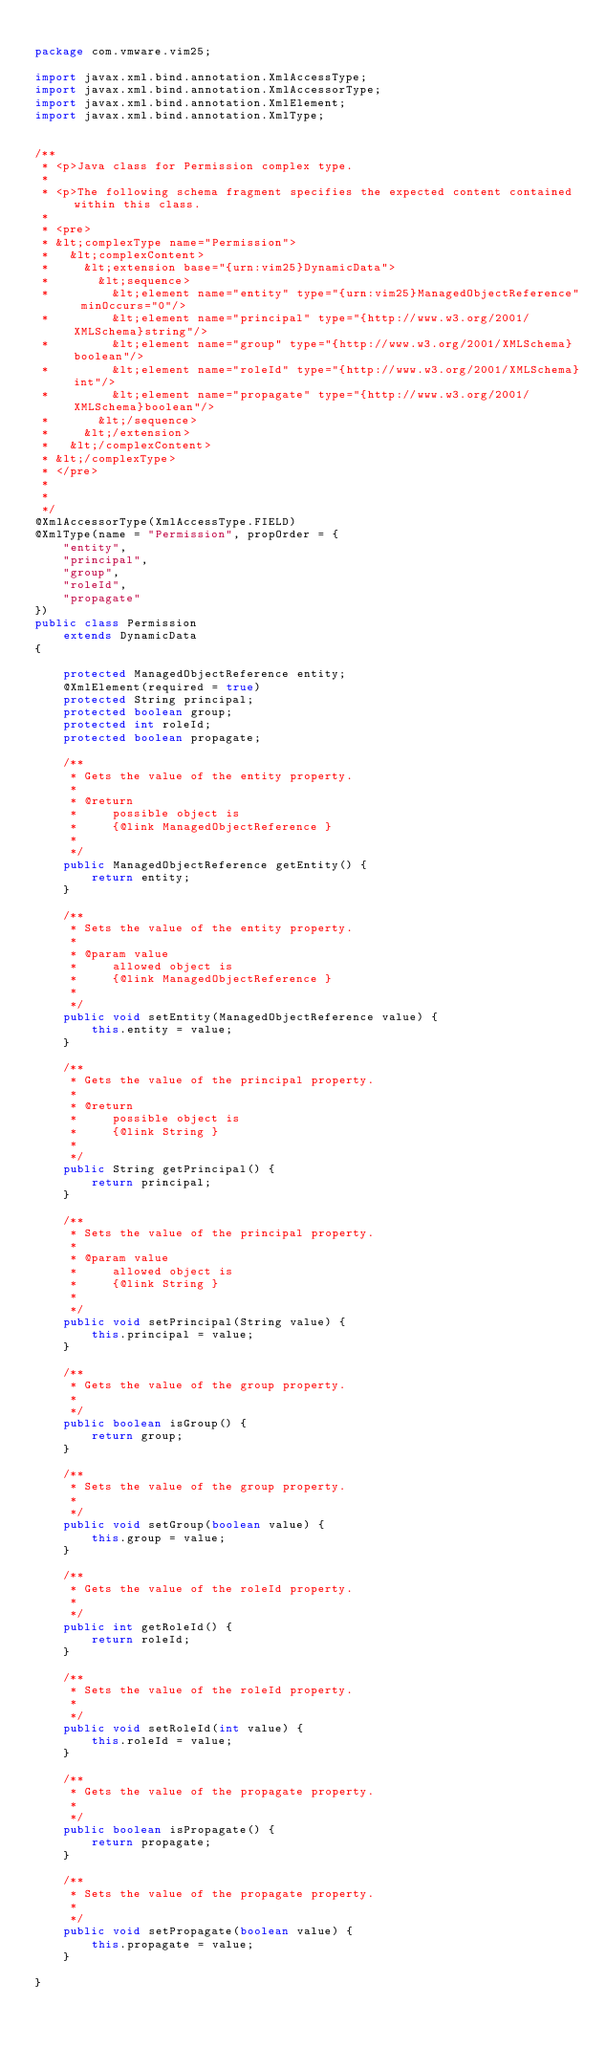<code> <loc_0><loc_0><loc_500><loc_500><_Java_>
package com.vmware.vim25;

import javax.xml.bind.annotation.XmlAccessType;
import javax.xml.bind.annotation.XmlAccessorType;
import javax.xml.bind.annotation.XmlElement;
import javax.xml.bind.annotation.XmlType;


/**
 * <p>Java class for Permission complex type.
 * 
 * <p>The following schema fragment specifies the expected content contained within this class.
 * 
 * <pre>
 * &lt;complexType name="Permission">
 *   &lt;complexContent>
 *     &lt;extension base="{urn:vim25}DynamicData">
 *       &lt;sequence>
 *         &lt;element name="entity" type="{urn:vim25}ManagedObjectReference" minOccurs="0"/>
 *         &lt;element name="principal" type="{http://www.w3.org/2001/XMLSchema}string"/>
 *         &lt;element name="group" type="{http://www.w3.org/2001/XMLSchema}boolean"/>
 *         &lt;element name="roleId" type="{http://www.w3.org/2001/XMLSchema}int"/>
 *         &lt;element name="propagate" type="{http://www.w3.org/2001/XMLSchema}boolean"/>
 *       &lt;/sequence>
 *     &lt;/extension>
 *   &lt;/complexContent>
 * &lt;/complexType>
 * </pre>
 * 
 * 
 */
@XmlAccessorType(XmlAccessType.FIELD)
@XmlType(name = "Permission", propOrder = {
    "entity",
    "principal",
    "group",
    "roleId",
    "propagate"
})
public class Permission
    extends DynamicData
{

    protected ManagedObjectReference entity;
    @XmlElement(required = true)
    protected String principal;
    protected boolean group;
    protected int roleId;
    protected boolean propagate;

    /**
     * Gets the value of the entity property.
     * 
     * @return
     *     possible object is
     *     {@link ManagedObjectReference }
     *     
     */
    public ManagedObjectReference getEntity() {
        return entity;
    }

    /**
     * Sets the value of the entity property.
     * 
     * @param value
     *     allowed object is
     *     {@link ManagedObjectReference }
     *     
     */
    public void setEntity(ManagedObjectReference value) {
        this.entity = value;
    }

    /**
     * Gets the value of the principal property.
     * 
     * @return
     *     possible object is
     *     {@link String }
     *     
     */
    public String getPrincipal() {
        return principal;
    }

    /**
     * Sets the value of the principal property.
     * 
     * @param value
     *     allowed object is
     *     {@link String }
     *     
     */
    public void setPrincipal(String value) {
        this.principal = value;
    }

    /**
     * Gets the value of the group property.
     * 
     */
    public boolean isGroup() {
        return group;
    }

    /**
     * Sets the value of the group property.
     * 
     */
    public void setGroup(boolean value) {
        this.group = value;
    }

    /**
     * Gets the value of the roleId property.
     * 
     */
    public int getRoleId() {
        return roleId;
    }

    /**
     * Sets the value of the roleId property.
     * 
     */
    public void setRoleId(int value) {
        this.roleId = value;
    }

    /**
     * Gets the value of the propagate property.
     * 
     */
    public boolean isPropagate() {
        return propagate;
    }

    /**
     * Sets the value of the propagate property.
     * 
     */
    public void setPropagate(boolean value) {
        this.propagate = value;
    }

}
</code> 